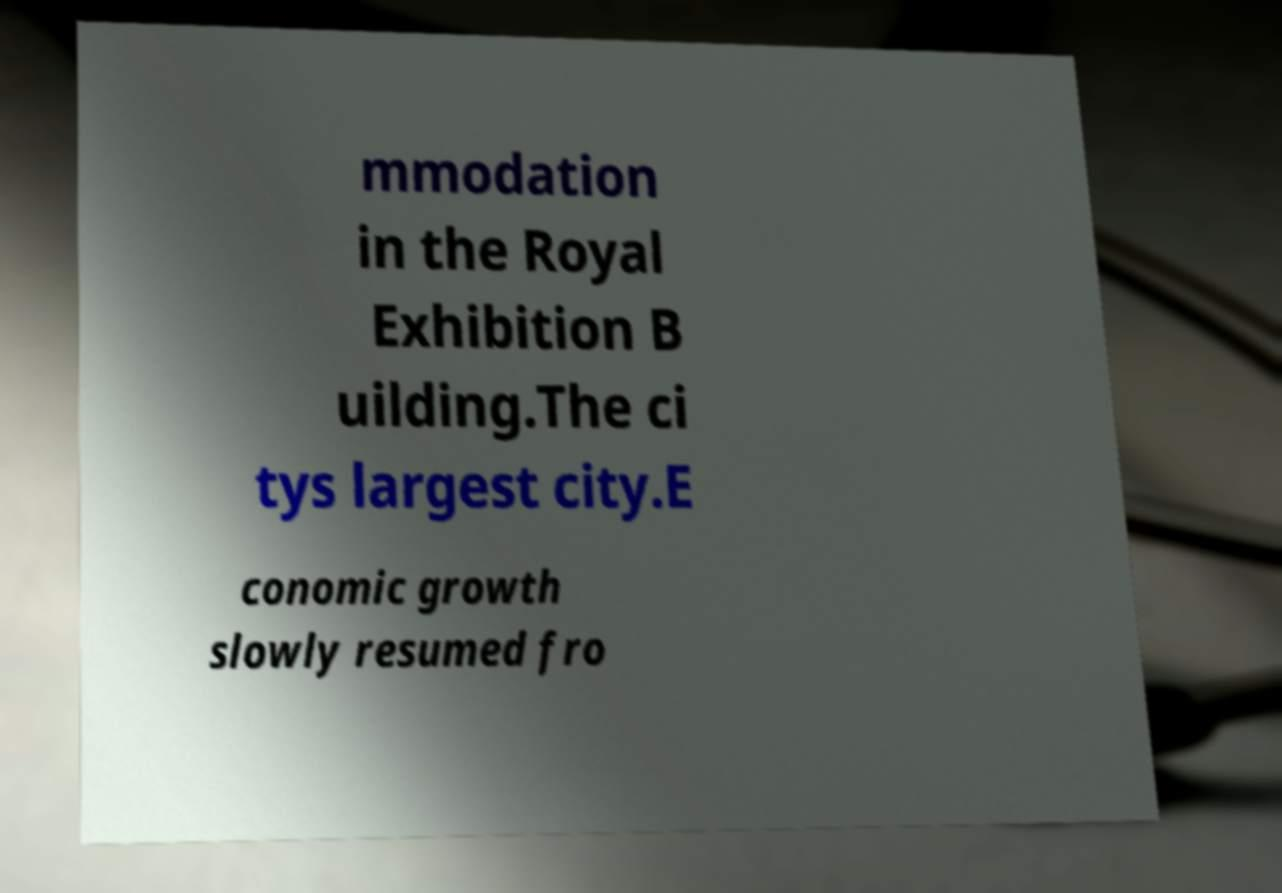Can you accurately transcribe the text from the provided image for me? mmodation in the Royal Exhibition B uilding.The ci tys largest city.E conomic growth slowly resumed fro 